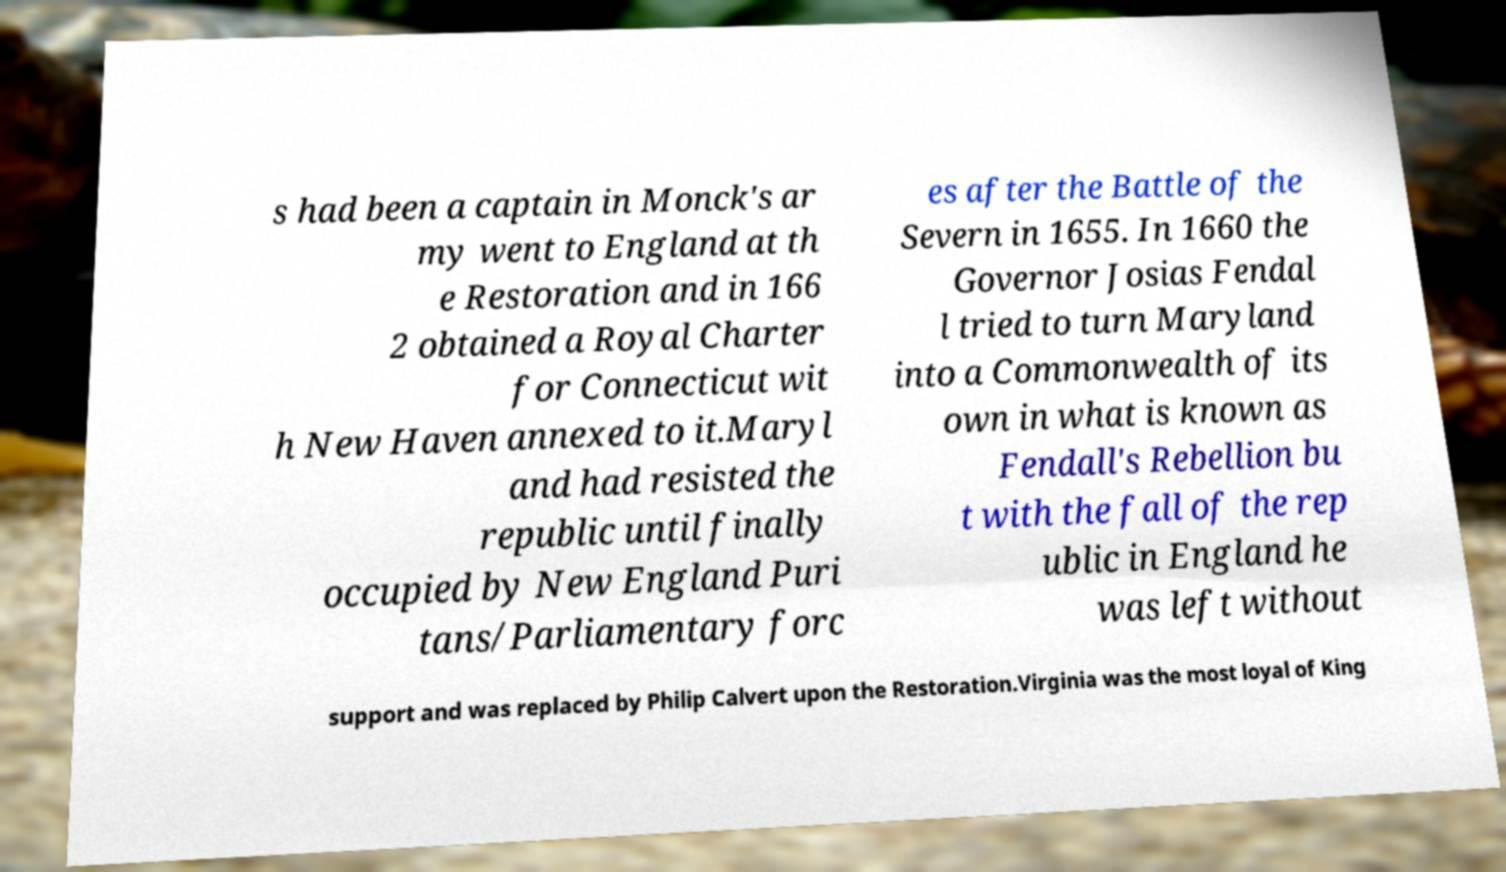Please read and relay the text visible in this image. What does it say? s had been a captain in Monck's ar my went to England at th e Restoration and in 166 2 obtained a Royal Charter for Connecticut wit h New Haven annexed to it.Maryl and had resisted the republic until finally occupied by New England Puri tans/Parliamentary forc es after the Battle of the Severn in 1655. In 1660 the Governor Josias Fendal l tried to turn Maryland into a Commonwealth of its own in what is known as Fendall's Rebellion bu t with the fall of the rep ublic in England he was left without support and was replaced by Philip Calvert upon the Restoration.Virginia was the most loyal of King 